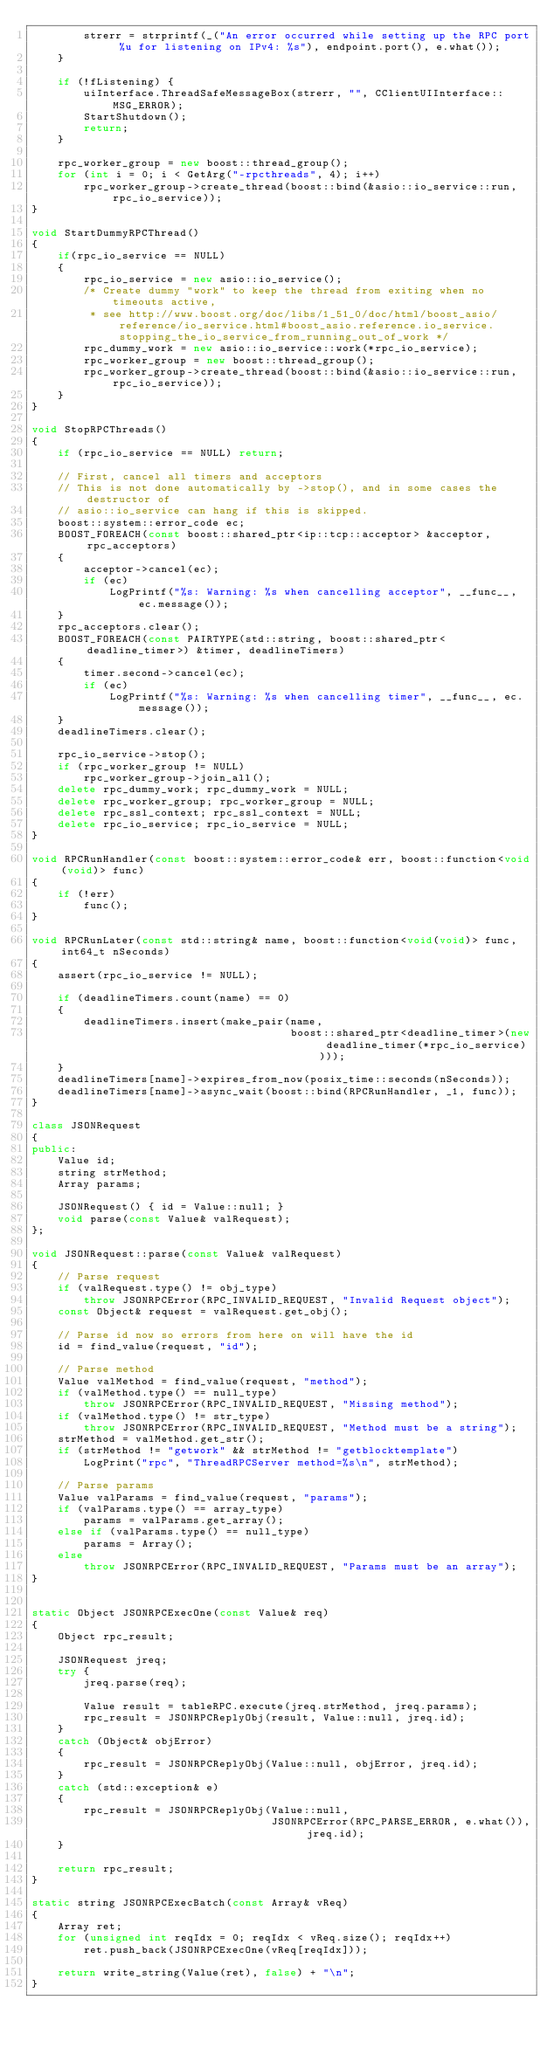Convert code to text. <code><loc_0><loc_0><loc_500><loc_500><_C++_>        strerr = strprintf(_("An error occurred while setting up the RPC port %u for listening on IPv4: %s"), endpoint.port(), e.what());
    }

    if (!fListening) {
        uiInterface.ThreadSafeMessageBox(strerr, "", CClientUIInterface::MSG_ERROR);
        StartShutdown();
        return;
    }

    rpc_worker_group = new boost::thread_group();
    for (int i = 0; i < GetArg("-rpcthreads", 4); i++)
        rpc_worker_group->create_thread(boost::bind(&asio::io_service::run, rpc_io_service));
}

void StartDummyRPCThread()
{
    if(rpc_io_service == NULL)
    {
        rpc_io_service = new asio::io_service();
        /* Create dummy "work" to keep the thread from exiting when no timeouts active,
         * see http://www.boost.org/doc/libs/1_51_0/doc/html/boost_asio/reference/io_service.html#boost_asio.reference.io_service.stopping_the_io_service_from_running_out_of_work */
        rpc_dummy_work = new asio::io_service::work(*rpc_io_service);
        rpc_worker_group = new boost::thread_group();
        rpc_worker_group->create_thread(boost::bind(&asio::io_service::run, rpc_io_service));
    }
}

void StopRPCThreads()
{
    if (rpc_io_service == NULL) return;

    // First, cancel all timers and acceptors
    // This is not done automatically by ->stop(), and in some cases the destructor of
    // asio::io_service can hang if this is skipped.
    boost::system::error_code ec;
    BOOST_FOREACH(const boost::shared_ptr<ip::tcp::acceptor> &acceptor, rpc_acceptors)
    {
        acceptor->cancel(ec);
        if (ec)
            LogPrintf("%s: Warning: %s when cancelling acceptor", __func__, ec.message());
    }
    rpc_acceptors.clear();
    BOOST_FOREACH(const PAIRTYPE(std::string, boost::shared_ptr<deadline_timer>) &timer, deadlineTimers)
    {
        timer.second->cancel(ec);
        if (ec)
            LogPrintf("%s: Warning: %s when cancelling timer", __func__, ec.message());
    }
    deadlineTimers.clear();

    rpc_io_service->stop();
    if (rpc_worker_group != NULL)
        rpc_worker_group->join_all();
    delete rpc_dummy_work; rpc_dummy_work = NULL;
    delete rpc_worker_group; rpc_worker_group = NULL;
    delete rpc_ssl_context; rpc_ssl_context = NULL;
    delete rpc_io_service; rpc_io_service = NULL;
}

void RPCRunHandler(const boost::system::error_code& err, boost::function<void(void)> func)
{
    if (!err)
        func();
}

void RPCRunLater(const std::string& name, boost::function<void(void)> func, int64_t nSeconds)
{
    assert(rpc_io_service != NULL);

    if (deadlineTimers.count(name) == 0)
    {
        deadlineTimers.insert(make_pair(name,
                                        boost::shared_ptr<deadline_timer>(new deadline_timer(*rpc_io_service))));
    }
    deadlineTimers[name]->expires_from_now(posix_time::seconds(nSeconds));
    deadlineTimers[name]->async_wait(boost::bind(RPCRunHandler, _1, func));
}

class JSONRequest
{
public:
    Value id;
    string strMethod;
    Array params;

    JSONRequest() { id = Value::null; }
    void parse(const Value& valRequest);
};

void JSONRequest::parse(const Value& valRequest)
{
    // Parse request
    if (valRequest.type() != obj_type)
        throw JSONRPCError(RPC_INVALID_REQUEST, "Invalid Request object");
    const Object& request = valRequest.get_obj();

    // Parse id now so errors from here on will have the id
    id = find_value(request, "id");

    // Parse method
    Value valMethod = find_value(request, "method");
    if (valMethod.type() == null_type)
        throw JSONRPCError(RPC_INVALID_REQUEST, "Missing method");
    if (valMethod.type() != str_type)
        throw JSONRPCError(RPC_INVALID_REQUEST, "Method must be a string");
    strMethod = valMethod.get_str();
    if (strMethod != "getwork" && strMethod != "getblocktemplate")
        LogPrint("rpc", "ThreadRPCServer method=%s\n", strMethod);

    // Parse params
    Value valParams = find_value(request, "params");
    if (valParams.type() == array_type)
        params = valParams.get_array();
    else if (valParams.type() == null_type)
        params = Array();
    else
        throw JSONRPCError(RPC_INVALID_REQUEST, "Params must be an array");
}


static Object JSONRPCExecOne(const Value& req)
{
    Object rpc_result;

    JSONRequest jreq;
    try {
        jreq.parse(req);

        Value result = tableRPC.execute(jreq.strMethod, jreq.params);
        rpc_result = JSONRPCReplyObj(result, Value::null, jreq.id);
    }
    catch (Object& objError)
    {
        rpc_result = JSONRPCReplyObj(Value::null, objError, jreq.id);
    }
    catch (std::exception& e)
    {
        rpc_result = JSONRPCReplyObj(Value::null,
                                     JSONRPCError(RPC_PARSE_ERROR, e.what()), jreq.id);
    }

    return rpc_result;
}

static string JSONRPCExecBatch(const Array& vReq)
{
    Array ret;
    for (unsigned int reqIdx = 0; reqIdx < vReq.size(); reqIdx++)
        ret.push_back(JSONRPCExecOne(vReq[reqIdx]));

    return write_string(Value(ret), false) + "\n";
}
</code> 